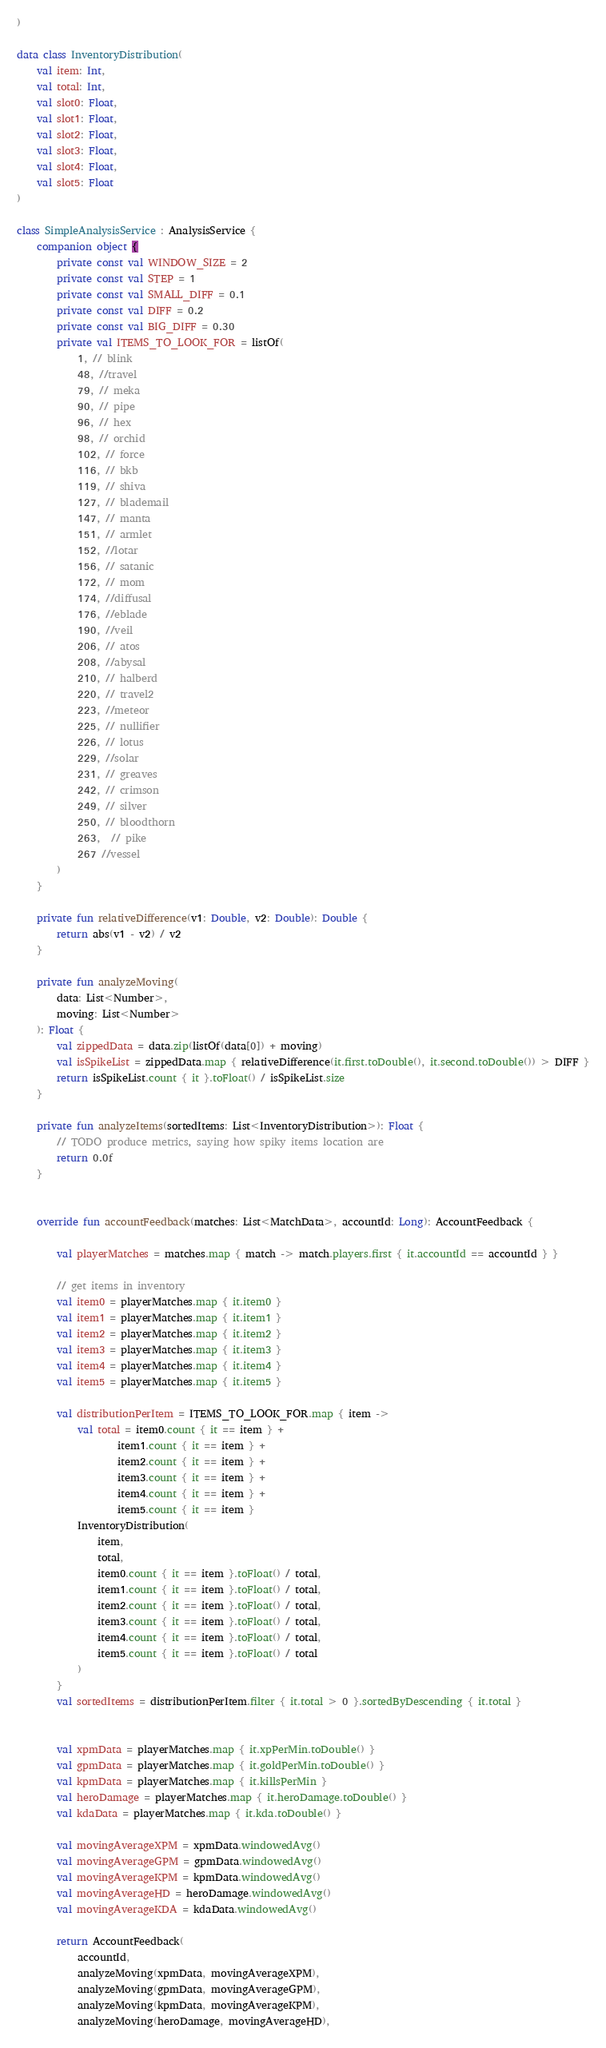Convert code to text. <code><loc_0><loc_0><loc_500><loc_500><_Kotlin_>)

data class InventoryDistribution(
    val item: Int,
    val total: Int,
    val slot0: Float,
    val slot1: Float,
    val slot2: Float,
    val slot3: Float,
    val slot4: Float,
    val slot5: Float
)

class SimpleAnalysisService : AnalysisService {
    companion object {
        private const val WINDOW_SIZE = 2
        private const val STEP = 1
        private const val SMALL_DIFF = 0.1
        private const val DIFF = 0.2
        private const val BIG_DIFF = 0.30
        private val ITEMS_TO_LOOK_FOR = listOf(
            1, // blink
            48, //travel
            79, // meka
            90, // pipe
            96, // hex
            98, // orchid
            102, // force
            116, // bkb
            119, // shiva
            127, // blademail
            147, // manta
            151, // armlet
            152, //lotar
            156, // satanic
            172, // mom
            174, //diffusal
            176, //eblade
            190, //veil
            206, // atos
            208, //abysal
            210, // halberd
            220, // travel2
            223, //meteor
            225, // nullifier
            226, // lotus
            229, //solar
            231, // greaves
            242, // crimson
            249, // silver
            250, // bloodthorn
            263,  // pike
            267 //vessel
        )
    }

    private fun relativeDifference(v1: Double, v2: Double): Double {
        return abs(v1 - v2) / v2
    }

    private fun analyzeMoving(
        data: List<Number>,
        moving: List<Number>
    ): Float {
        val zippedData = data.zip(listOf(data[0]) + moving)
        val isSpikeList = zippedData.map { relativeDifference(it.first.toDouble(), it.second.toDouble()) > DIFF }
        return isSpikeList.count { it }.toFloat() / isSpikeList.size
    }

    private fun analyzeItems(sortedItems: List<InventoryDistribution>): Float {
        // TODO produce metrics, saying how spiky items location are
        return 0.0f
    }


    override fun accountFeedback(matches: List<MatchData>, accountId: Long): AccountFeedback {

        val playerMatches = matches.map { match -> match.players.first { it.accountId == accountId } }

        // get items in inventory
        val item0 = playerMatches.map { it.item0 }
        val item1 = playerMatches.map { it.item1 }
        val item2 = playerMatches.map { it.item2 }
        val item3 = playerMatches.map { it.item3 }
        val item4 = playerMatches.map { it.item4 }
        val item5 = playerMatches.map { it.item5 }

        val distributionPerItem = ITEMS_TO_LOOK_FOR.map { item ->
            val total = item0.count { it == item } +
                    item1.count { it == item } +
                    item2.count { it == item } +
                    item3.count { it == item } +
                    item4.count { it == item } +
                    item5.count { it == item }
            InventoryDistribution(
                item,
                total,
                item0.count { it == item }.toFloat() / total,
                item1.count { it == item }.toFloat() / total,
                item2.count { it == item }.toFloat() / total,
                item3.count { it == item }.toFloat() / total,
                item4.count { it == item }.toFloat() / total,
                item5.count { it == item }.toFloat() / total
            )
        }
        val sortedItems = distributionPerItem.filter { it.total > 0 }.sortedByDescending { it.total }


        val xpmData = playerMatches.map { it.xpPerMin.toDouble() }
        val gpmData = playerMatches.map { it.goldPerMin.toDouble() }
        val kpmData = playerMatches.map { it.killsPerMin }
        val heroDamage = playerMatches.map { it.heroDamage.toDouble() }
        val kdaData = playerMatches.map { it.kda.toDouble() }

        val movingAverageXPM = xpmData.windowedAvg()
        val movingAverageGPM = gpmData.windowedAvg()
        val movingAverageKPM = kpmData.windowedAvg()
        val movingAverageHD = heroDamage.windowedAvg()
        val movingAverageKDA = kdaData.windowedAvg()

        return AccountFeedback(
            accountId,
            analyzeMoving(xpmData, movingAverageXPM),
            analyzeMoving(gpmData, movingAverageGPM),
            analyzeMoving(kpmData, movingAverageKPM),
            analyzeMoving(heroDamage, movingAverageHD),</code> 